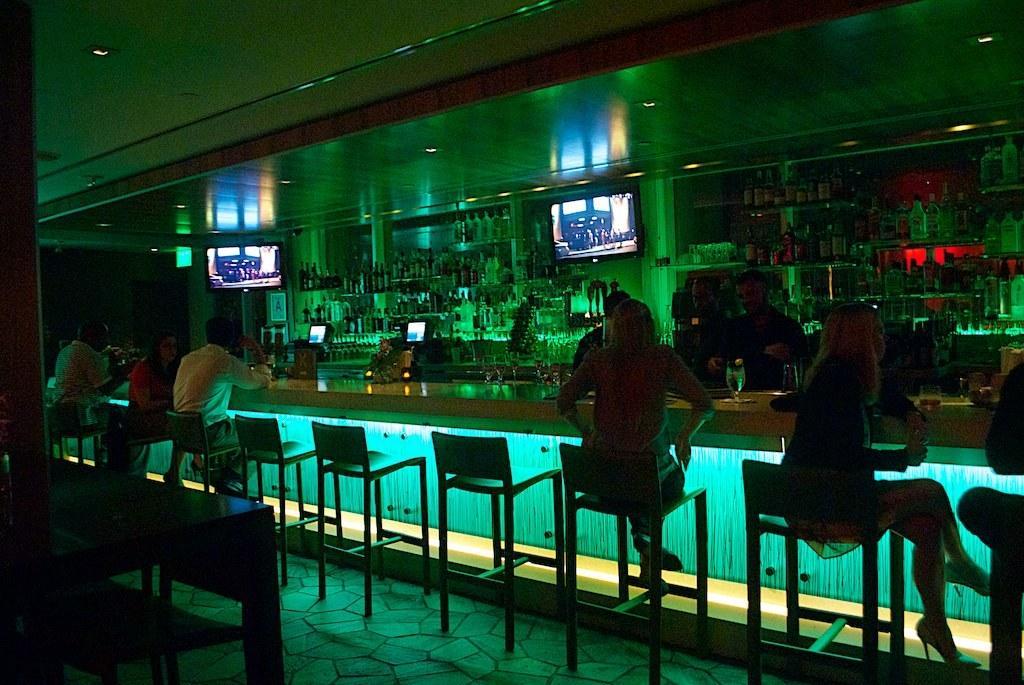Could you give a brief overview of what you see in this image? In this image i can see there is a group of people who are sitting on a chair in front of a table. Here I can see the group of bottles, few TVs on the wall. 